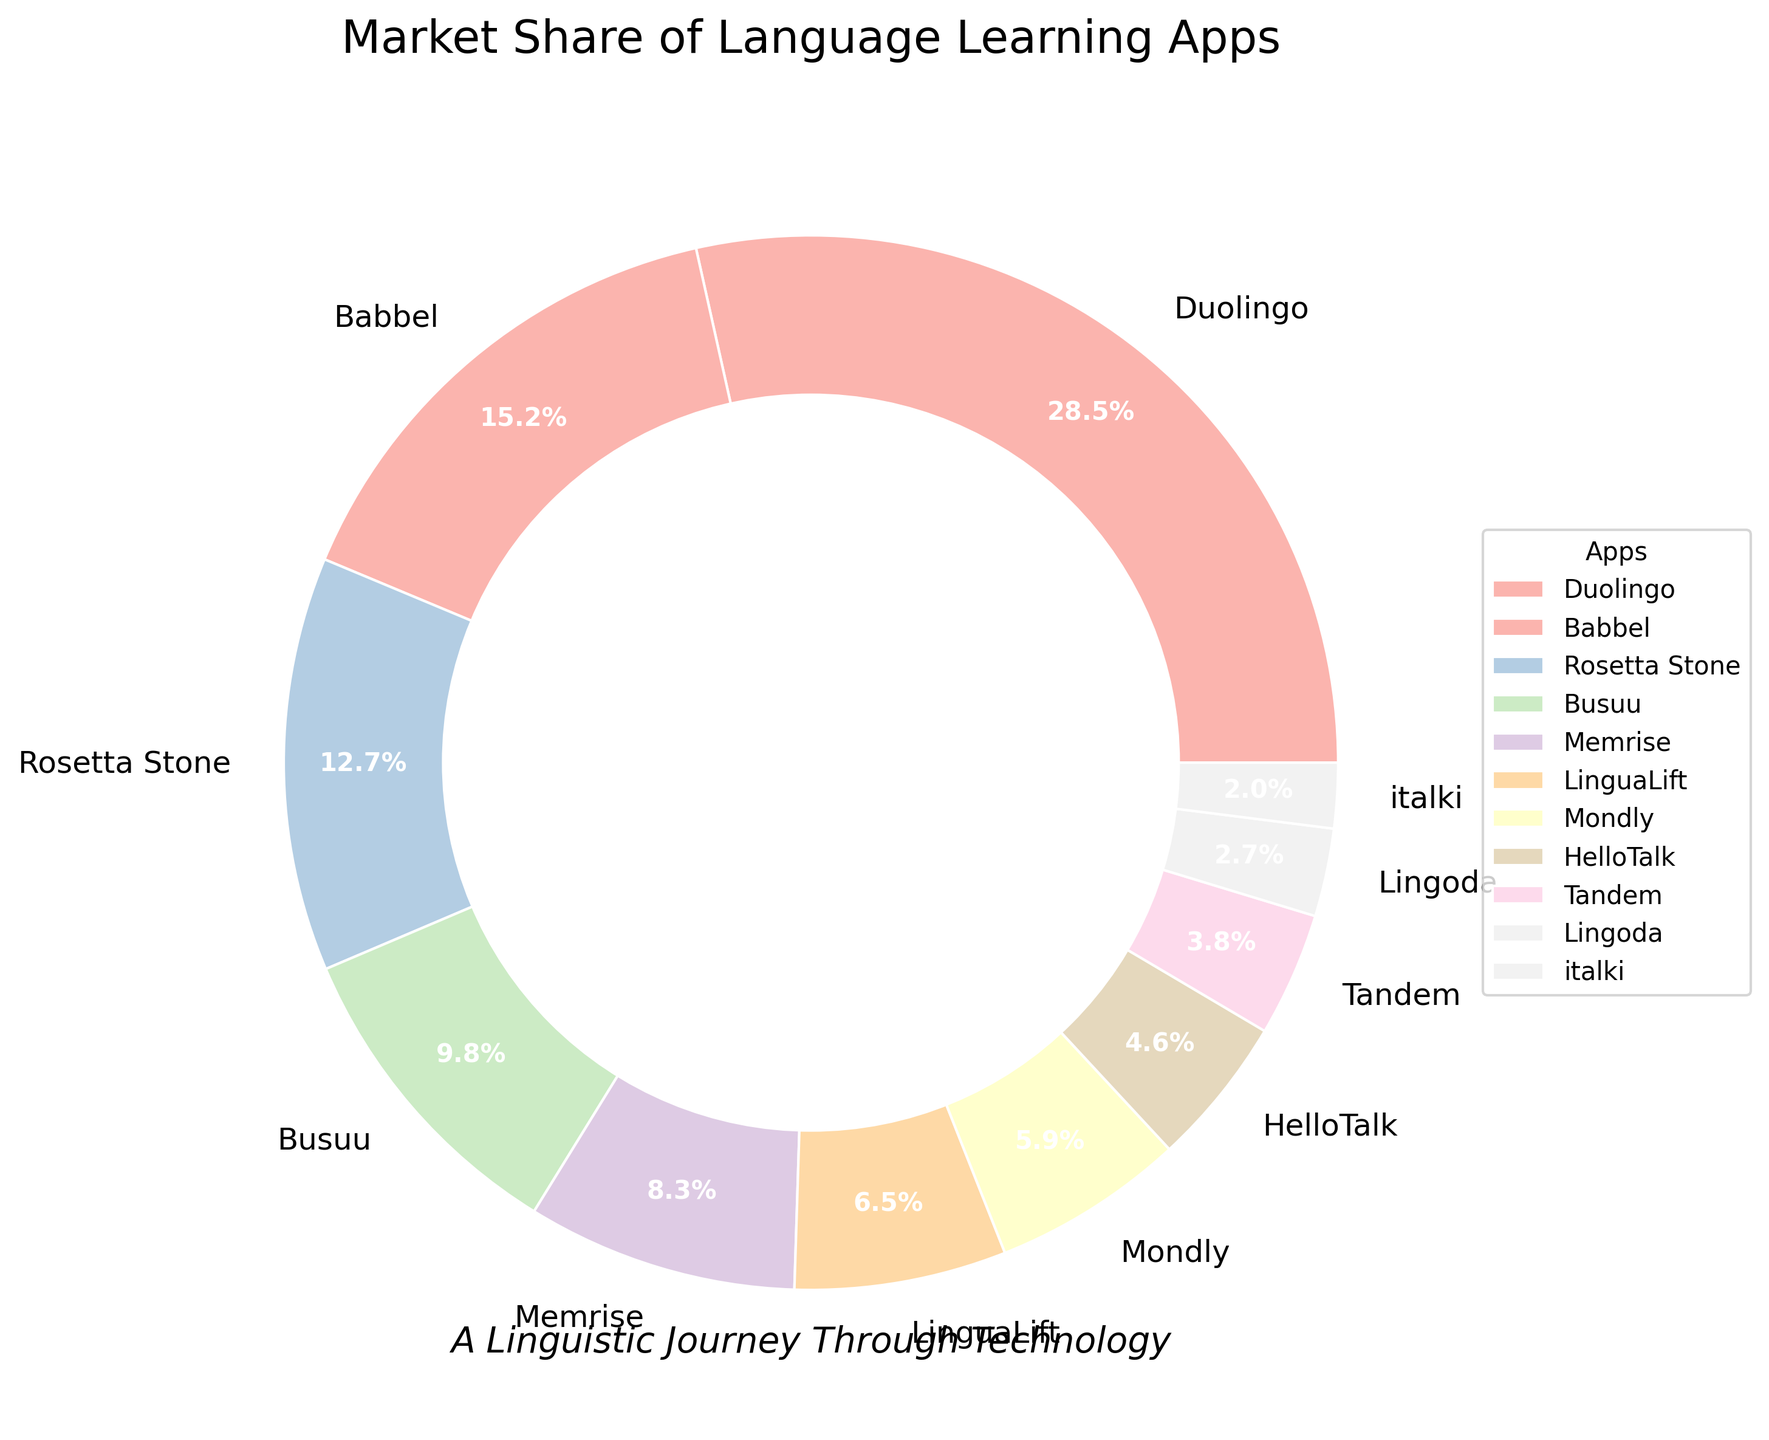what's the market share difference between Duolingo and Babbel? Duolingo has a market share of 28.5%, and Babbel has a market share of 15.2%. Their difference is 28.5 - 15.2 = 13.3.
Answer: 13.3% which app has the smallest market share? The app with the smallest market share is italki with 2.0%.
Answer: italki What is the combined market share of Rosetta Stone, Busuu, and Memrise? Rosetta Stone has 12.7%, Busuu has 9.8%, and Memrise has 8.3%. The combined market share is 12.7 + 9.8 + 8.3 = 30.8%.
Answer: 30.8% Of the apps displayed, which one is nearest the center in the donut chart and shares the smallest section? The app nearest the center and smallest is italki as it has the smallest market share.
Answer: italki Compare the market share of LinguaLift and HelloTalk. Which one has more? LinguaLift has a market share of 6.5%, and HelloTalk has 4.6%. LinguaLift has more.
Answer: LinguaLift Which two apps have a combined market share of under 10%? Tandem has 3.8% and Lingoda has 2.7%. Their combined share is 3.8 + 2.7 = 6.5%, which is under 10%.
Answer: Tandem and Lingoda How much higher is Duolingo's market share compared to Mondly's? Duolingo's market share is 28.5%, and Mondly's is 5.9%. The difference is 28.5 - 5.9 = 22.6%.
Answer: 22.6% What's the average market share of the top 5 apps? Duolingo, Babbel, Rosetta Stone, Busuu, and Memrise are the top 5 apps. Their shares are 28.5%, 15.2%, 12.7%, 9.8%, and 8.3%. The total is 28.5 + 15.2 + 12.7 + 9.8 + 8.3 = 74.5, and the average is 74.5 / 5 = 14.9%.
Answer: 14.9% Which app has a market share closest to 9%? Busuu has a market share of 9.8%, which is closest to 9%.
Answer: Busuu 